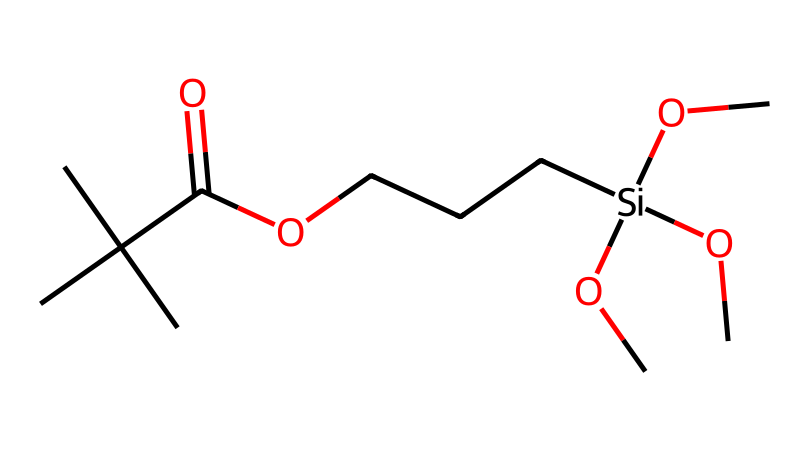What is the total number of carbon atoms in this chemical? To find the total number of carbon atoms, identify each carbon (C) in the SMILES representation. Counting yields seven carbon atoms: three in the tert-butyl group, one in the carbonyl, one in the ether linkage, and two in the silane part.
Answer: seven How many oxygen atoms are present in this chemical? The number of oxygen (O) atoms can be counted in the SMILES notation. There are three oxygen atoms from the ethers and one from the carboxylic acid, leading to a total of four.
Answer: four What type of chemical functional group is represented by "C(=O)O"? The notation "C(=O)O" indicates a carbon atom double-bonded to an oxygen atom and single-bonded to another oxygen that is also bonded to a hydrogen (indicative of the carboxylic acid group).
Answer: carboxylic acid What is the overall classification of this chemical based on the presence of silicon? This compound contains a silicon (Si) atom covalently bonded to oxygen and carbon atoms, classifying it as a silane-modified polymer.
Answer: silane-modified polymer How many total bonds are connected to the silicon atom in the chemical structure? The silicon (Si) atom has four substituents: three methoxy groups (O-CH3) and a carbon atom (part of the polymer backbone), giving it a total of four bonds.
Answer: four Which part of this chemical contributes to easy clean properties? The presence of the silane part with ether functionalities (–Si–O–) contributes to the smooth surface and hydrophobic characteristics, aiding in easy cleaning.
Answer: silane part 